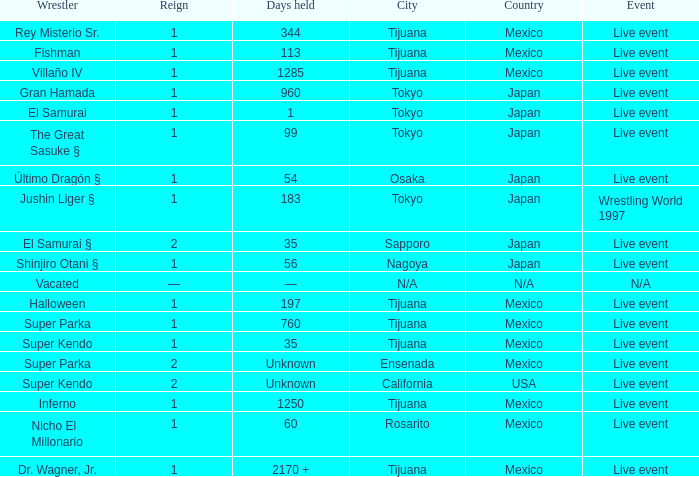What type of event had the wrestler with a reign of 2 and held the title for 35 days? Live event. Help me parse the entirety of this table. {'header': ['Wrestler', 'Reign', 'Days held', 'City', 'Country', 'Event'], 'rows': [['Rey Misterio Sr.', '1', '344', 'Tijuana', 'Mexico', 'Live event'], ['Fishman', '1', '113', 'Tijuana', 'Mexico', 'Live event'], ['Villaño IV', '1', '1285', 'Tijuana', 'Mexico', 'Live event'], ['Gran Hamada', '1', '960', 'Tokyo', 'Japan', 'Live event'], ['El Samurai', '1', '1', 'Tokyo', 'Japan', 'Live event'], ['The Great Sasuke §', '1', '99', 'Tokyo', 'Japan', 'Live event'], ['Último Dragón §', '1', '54', 'Osaka', 'Japan', 'Live event'], ['Jushin Liger §', '1', '183', 'Tokyo', 'Japan', 'Wrestling World 1997'], ['El Samurai §', '2', '35', 'Sapporo', 'Japan', 'Live event'], ['Shinjiro Otani §', '1', '56', 'Nagoya', 'Japan', 'Live event'], ['Vacated', '—', '—', 'N/A', 'N/A', 'N/A'], ['Halloween', '1', '197', 'Tijuana', 'Mexico', 'Live event'], ['Super Parka', '1', '760', 'Tijuana', 'Mexico', 'Live event'], ['Super Kendo', '1', '35', 'Tijuana', 'Mexico', 'Live event'], ['Super Parka', '2', 'Unknown', 'Ensenada', 'Mexico', 'Live event'], ['Super Kendo', '2', 'Unknown', 'California', 'USA', 'Live event'], ['Inferno', '1', '1250', 'Tijuana', 'Mexico', 'Live event'], ['Nicho El Millonario', '1', '60', 'Rosarito', 'Mexico', 'Live event'], ['Dr. Wagner, Jr.', '1', '2170 +', 'Tijuana', 'Mexico', 'Live event']]} 